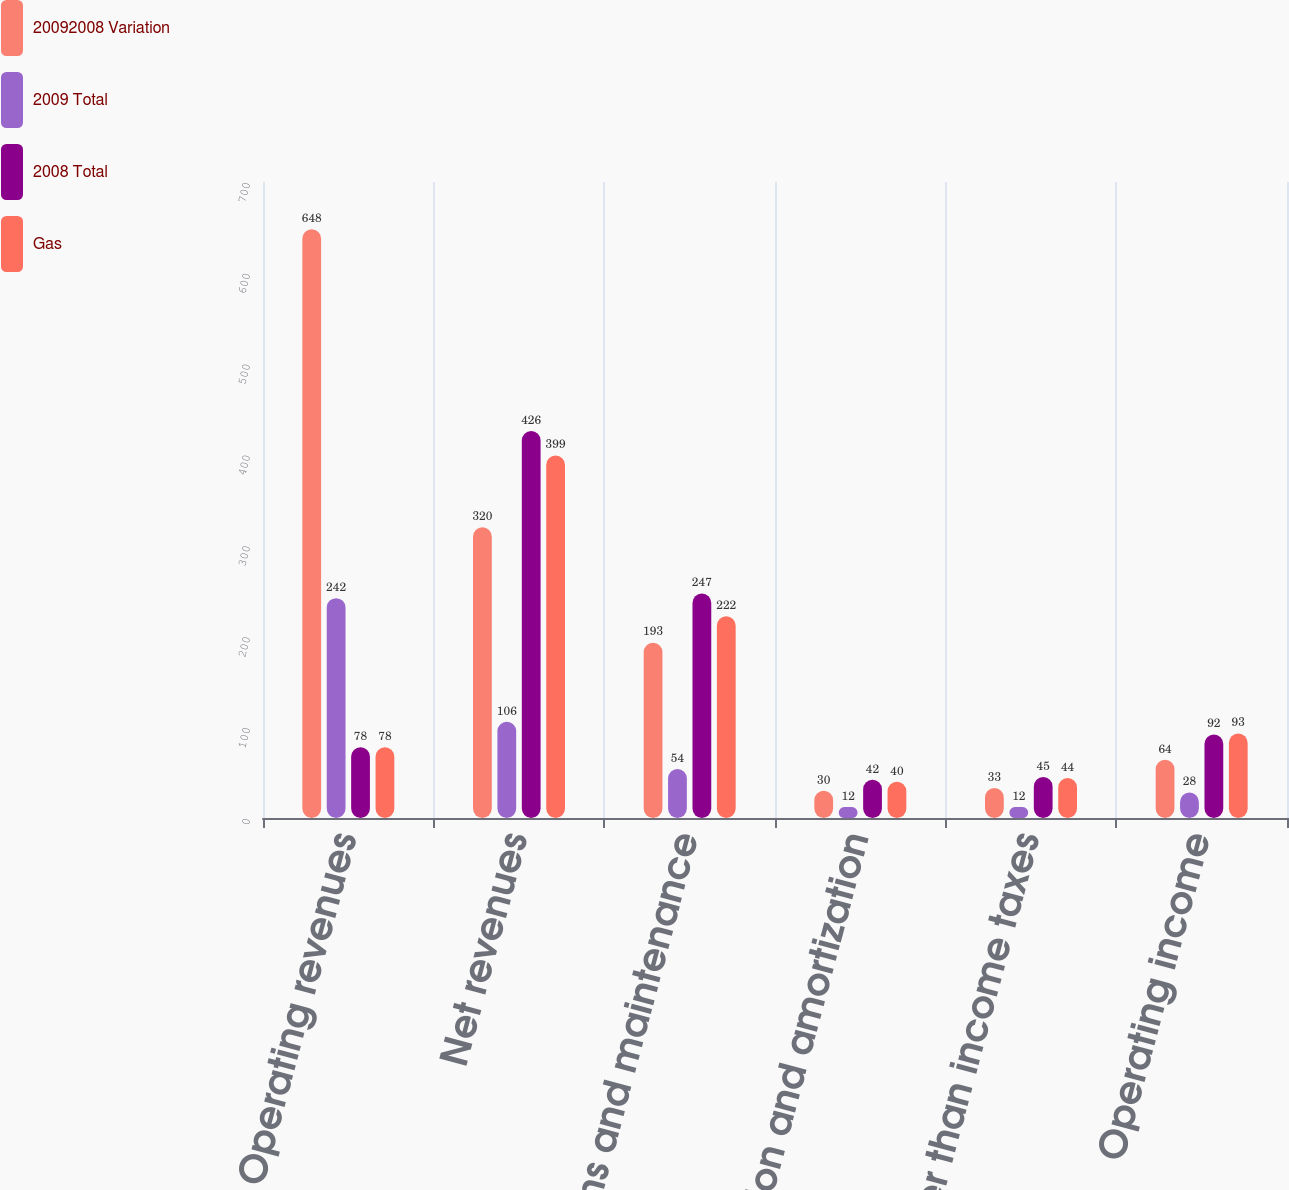Convert chart. <chart><loc_0><loc_0><loc_500><loc_500><stacked_bar_chart><ecel><fcel>Operating revenues<fcel>Net revenues<fcel>Operations and maintenance<fcel>Depreciation and amortization<fcel>Taxes other than income taxes<fcel>Operating income<nl><fcel>20092008 Variation<fcel>648<fcel>320<fcel>193<fcel>30<fcel>33<fcel>64<nl><fcel>2009 Total<fcel>242<fcel>106<fcel>54<fcel>12<fcel>12<fcel>28<nl><fcel>2008 Total<fcel>78<fcel>426<fcel>247<fcel>42<fcel>45<fcel>92<nl><fcel>Gas<fcel>78<fcel>399<fcel>222<fcel>40<fcel>44<fcel>93<nl></chart> 